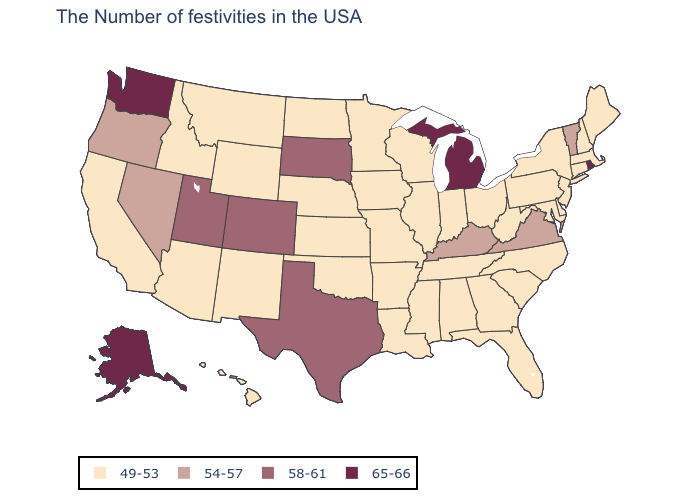Which states have the highest value in the USA?
Write a very short answer. Rhode Island, Michigan, Washington, Alaska. Does Arkansas have a lower value than Vermont?
Be succinct. Yes. Does the first symbol in the legend represent the smallest category?
Keep it brief. Yes. Which states have the highest value in the USA?
Short answer required. Rhode Island, Michigan, Washington, Alaska. Does the first symbol in the legend represent the smallest category?
Write a very short answer. Yes. Among the states that border Wisconsin , does Michigan have the highest value?
Concise answer only. Yes. Among the states that border West Virginia , which have the lowest value?
Give a very brief answer. Maryland, Pennsylvania, Ohio. What is the value of Mississippi?
Short answer required. 49-53. Among the states that border South Dakota , which have the highest value?
Be succinct. Minnesota, Iowa, Nebraska, North Dakota, Wyoming, Montana. Does Virginia have the same value as Oregon?
Concise answer only. Yes. What is the value of Tennessee?
Keep it brief. 49-53. Does the map have missing data?
Concise answer only. No. How many symbols are there in the legend?
Short answer required. 4. What is the value of Utah?
Write a very short answer. 58-61. Among the states that border Wyoming , does Montana have the highest value?
Give a very brief answer. No. 